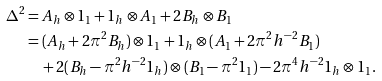<formula> <loc_0><loc_0><loc_500><loc_500>\Delta ^ { 2 } & = A _ { h } \otimes 1 _ { 1 } + 1 _ { h } \otimes A _ { 1 } + 2 B _ { h } \otimes B _ { 1 } \\ & = ( A _ { h } + 2 \pi ^ { 2 } B _ { h } ) \otimes 1 _ { 1 } + 1 _ { h } \otimes ( A _ { 1 } + 2 \pi ^ { 2 } h ^ { - 2 } B _ { 1 } ) \\ & \quad + 2 ( B _ { h } - \pi ^ { 2 } h ^ { - 2 } 1 _ { h } ) \otimes ( B _ { 1 } - \pi ^ { 2 } 1 _ { 1 } ) - 2 \pi ^ { 4 } h ^ { - 2 } 1 _ { h } \otimes 1 _ { 1 } .</formula> 